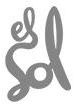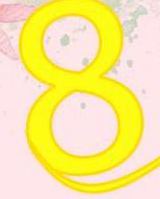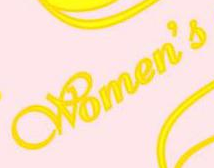What words are shown in these images in order, separated by a semicolon? Sol; 8; Women's 